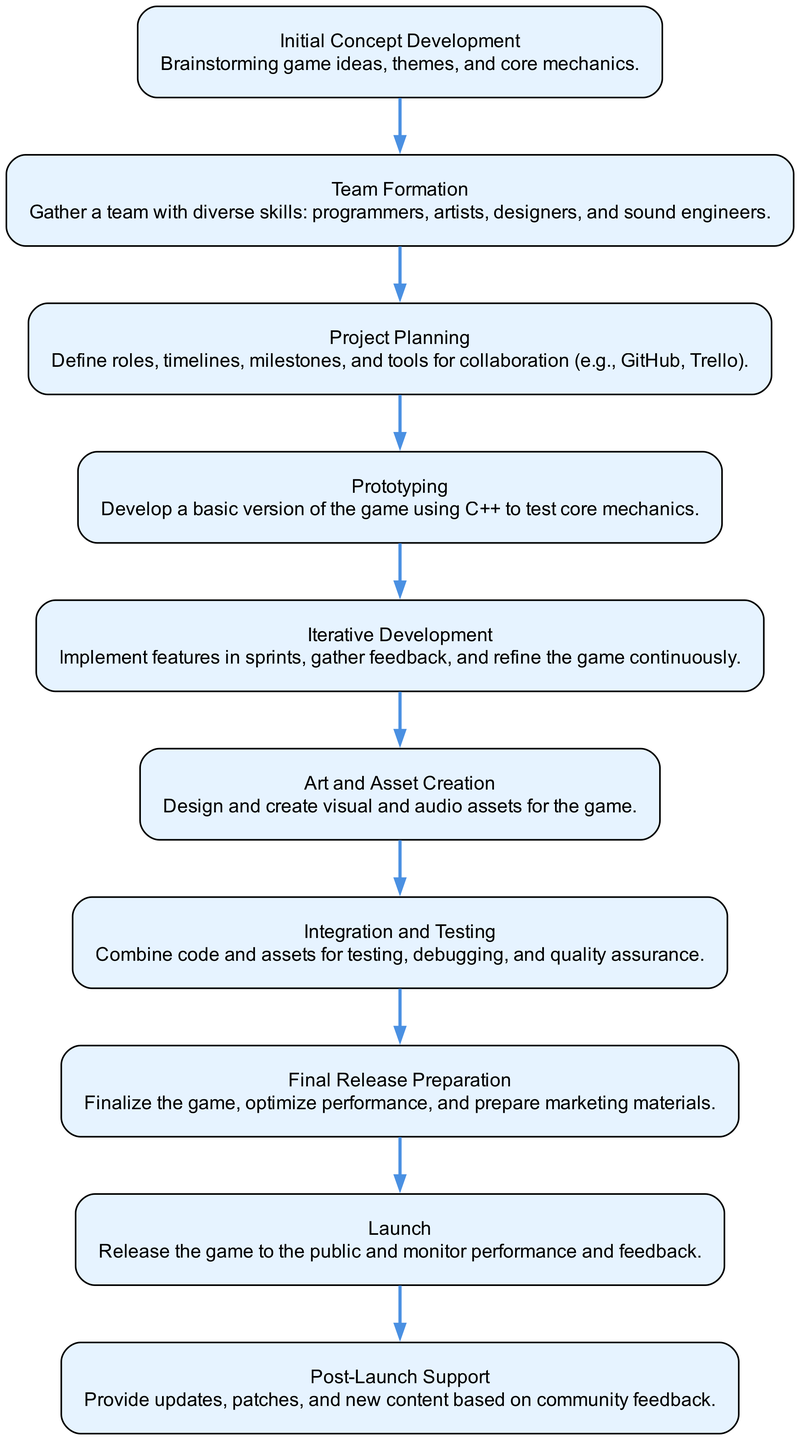What is the first step in the workflow? The diagram clearly shows that the first node lists "Initial Concept Development" as the starting point of the workflow, indicating it is the initial step.
Answer: Initial Concept Development How many nodes are in the diagram? By counting the number of unique steps listed in the diagram, we find there are ten distinct elements, each represented as a node.
Answer: 10 What follows "Art and Asset Creation"? Looking at the flow of the diagram, the node that comes directly after "Art and Asset Creation" is "Integration and Testing," indicating this is the next step.
Answer: Integration and Testing Which two nodes are connected by an edge leading to "Launch"? By tracing backward from the "Launch" node, we see that it is directly connected from "Final Release Preparation," as this step precedes the launching of the game.
Answer: Final Release Preparation What is the last step of the game development workflow? The diagram shows that the final node listed is "Post-Launch Support," making it clear that this is the concluding phase of the collaborative workflow.
Answer: Post-Launch Support What is the main purpose of "Iterative Development"? The description of "Iterative Development" specifies that it is about continuously implementing features in sprints and gathering feedback to refine the game, hence it serves the purpose of ongoing improvement.
Answer: Implement features and refine Which node comes after "Prototyping"? Observing the flow, "Iterative Development" follows "Prototyping" in the sequence, indicating it comes directly after completing the prototype phase of the game.
Answer: Iterative Development What is required in "Team Formation"? The description associated with "Team Formation" indicates the necessity of gathering a team with diverse skills such as programmers, artists, designers, and sound engineers.
Answer: Diverse skills What is the relationship between "Project Planning" and "Team Formation"? The diagram visually indicates that "Project Planning" occurs after "Team Formation," showing that once the team is formed, project roles and timelines can be established.
Answer: Sequential steps 